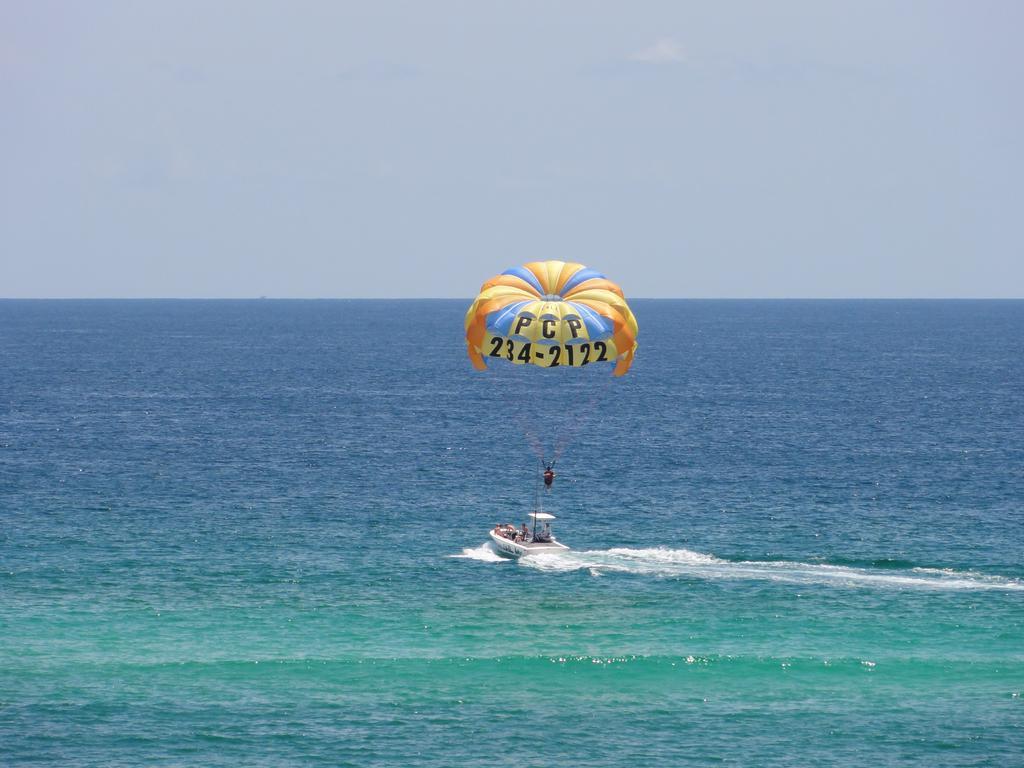Could you give a brief overview of what you see in this image? In the center of the image we can see a parachute and a boat in the water. In the background, we can see the sky. 